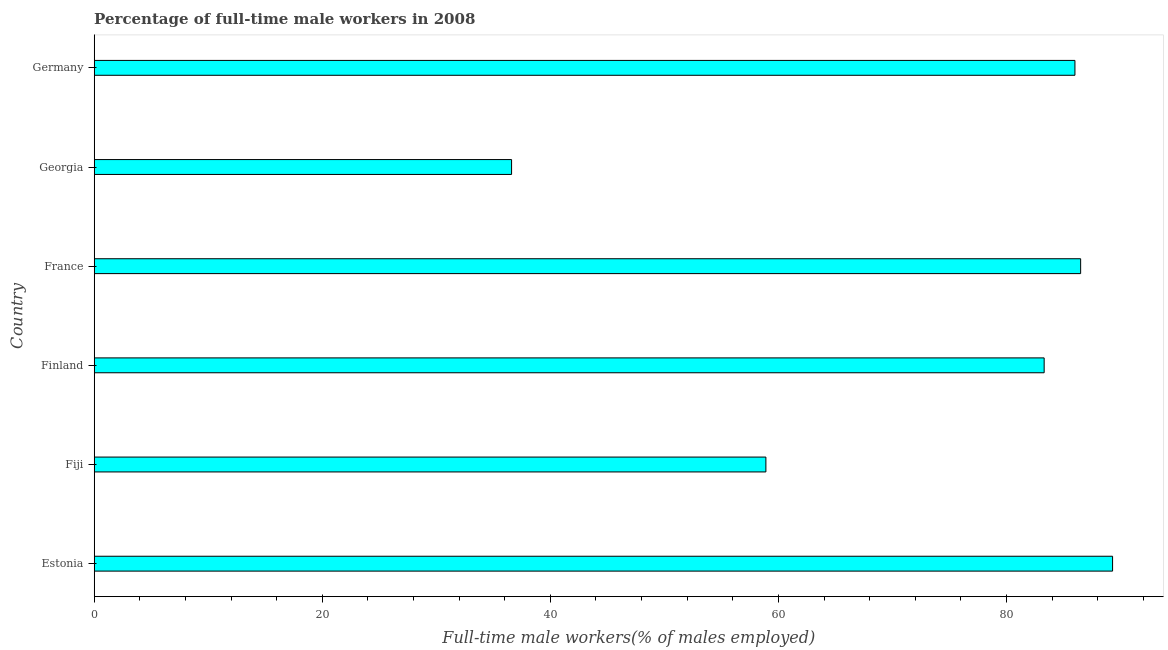Does the graph contain any zero values?
Make the answer very short. No. What is the title of the graph?
Give a very brief answer. Percentage of full-time male workers in 2008. What is the label or title of the X-axis?
Provide a succinct answer. Full-time male workers(% of males employed). What is the label or title of the Y-axis?
Provide a succinct answer. Country. What is the percentage of full-time male workers in Fiji?
Provide a succinct answer. 58.9. Across all countries, what is the maximum percentage of full-time male workers?
Make the answer very short. 89.3. Across all countries, what is the minimum percentage of full-time male workers?
Give a very brief answer. 36.6. In which country was the percentage of full-time male workers maximum?
Provide a succinct answer. Estonia. In which country was the percentage of full-time male workers minimum?
Provide a short and direct response. Georgia. What is the sum of the percentage of full-time male workers?
Give a very brief answer. 440.6. What is the difference between the percentage of full-time male workers in Fiji and Germany?
Your response must be concise. -27.1. What is the average percentage of full-time male workers per country?
Offer a terse response. 73.43. What is the median percentage of full-time male workers?
Ensure brevity in your answer.  84.65. In how many countries, is the percentage of full-time male workers greater than 4 %?
Offer a terse response. 6. What is the ratio of the percentage of full-time male workers in Finland to that in Germany?
Your answer should be very brief. 0.97. What is the difference between the highest and the second highest percentage of full-time male workers?
Offer a very short reply. 2.8. What is the difference between the highest and the lowest percentage of full-time male workers?
Make the answer very short. 52.7. In how many countries, is the percentage of full-time male workers greater than the average percentage of full-time male workers taken over all countries?
Offer a very short reply. 4. How many bars are there?
Keep it short and to the point. 6. What is the Full-time male workers(% of males employed) in Estonia?
Your answer should be compact. 89.3. What is the Full-time male workers(% of males employed) in Fiji?
Your response must be concise. 58.9. What is the Full-time male workers(% of males employed) of Finland?
Ensure brevity in your answer.  83.3. What is the Full-time male workers(% of males employed) of France?
Offer a terse response. 86.5. What is the Full-time male workers(% of males employed) in Georgia?
Provide a succinct answer. 36.6. What is the difference between the Full-time male workers(% of males employed) in Estonia and Fiji?
Offer a terse response. 30.4. What is the difference between the Full-time male workers(% of males employed) in Estonia and France?
Your answer should be compact. 2.8. What is the difference between the Full-time male workers(% of males employed) in Estonia and Georgia?
Ensure brevity in your answer.  52.7. What is the difference between the Full-time male workers(% of males employed) in Fiji and Finland?
Give a very brief answer. -24.4. What is the difference between the Full-time male workers(% of males employed) in Fiji and France?
Offer a terse response. -27.6. What is the difference between the Full-time male workers(% of males employed) in Fiji and Georgia?
Your response must be concise. 22.3. What is the difference between the Full-time male workers(% of males employed) in Fiji and Germany?
Offer a very short reply. -27.1. What is the difference between the Full-time male workers(% of males employed) in Finland and France?
Ensure brevity in your answer.  -3.2. What is the difference between the Full-time male workers(% of males employed) in Finland and Georgia?
Your answer should be very brief. 46.7. What is the difference between the Full-time male workers(% of males employed) in Finland and Germany?
Give a very brief answer. -2.7. What is the difference between the Full-time male workers(% of males employed) in France and Georgia?
Offer a very short reply. 49.9. What is the difference between the Full-time male workers(% of males employed) in France and Germany?
Give a very brief answer. 0.5. What is the difference between the Full-time male workers(% of males employed) in Georgia and Germany?
Make the answer very short. -49.4. What is the ratio of the Full-time male workers(% of males employed) in Estonia to that in Fiji?
Provide a short and direct response. 1.52. What is the ratio of the Full-time male workers(% of males employed) in Estonia to that in Finland?
Give a very brief answer. 1.07. What is the ratio of the Full-time male workers(% of males employed) in Estonia to that in France?
Give a very brief answer. 1.03. What is the ratio of the Full-time male workers(% of males employed) in Estonia to that in Georgia?
Your answer should be very brief. 2.44. What is the ratio of the Full-time male workers(% of males employed) in Estonia to that in Germany?
Offer a terse response. 1.04. What is the ratio of the Full-time male workers(% of males employed) in Fiji to that in Finland?
Keep it short and to the point. 0.71. What is the ratio of the Full-time male workers(% of males employed) in Fiji to that in France?
Provide a short and direct response. 0.68. What is the ratio of the Full-time male workers(% of males employed) in Fiji to that in Georgia?
Your answer should be compact. 1.61. What is the ratio of the Full-time male workers(% of males employed) in Fiji to that in Germany?
Your answer should be very brief. 0.69. What is the ratio of the Full-time male workers(% of males employed) in Finland to that in France?
Your answer should be very brief. 0.96. What is the ratio of the Full-time male workers(% of males employed) in Finland to that in Georgia?
Offer a terse response. 2.28. What is the ratio of the Full-time male workers(% of males employed) in Finland to that in Germany?
Provide a succinct answer. 0.97. What is the ratio of the Full-time male workers(% of males employed) in France to that in Georgia?
Provide a short and direct response. 2.36. What is the ratio of the Full-time male workers(% of males employed) in Georgia to that in Germany?
Offer a terse response. 0.43. 